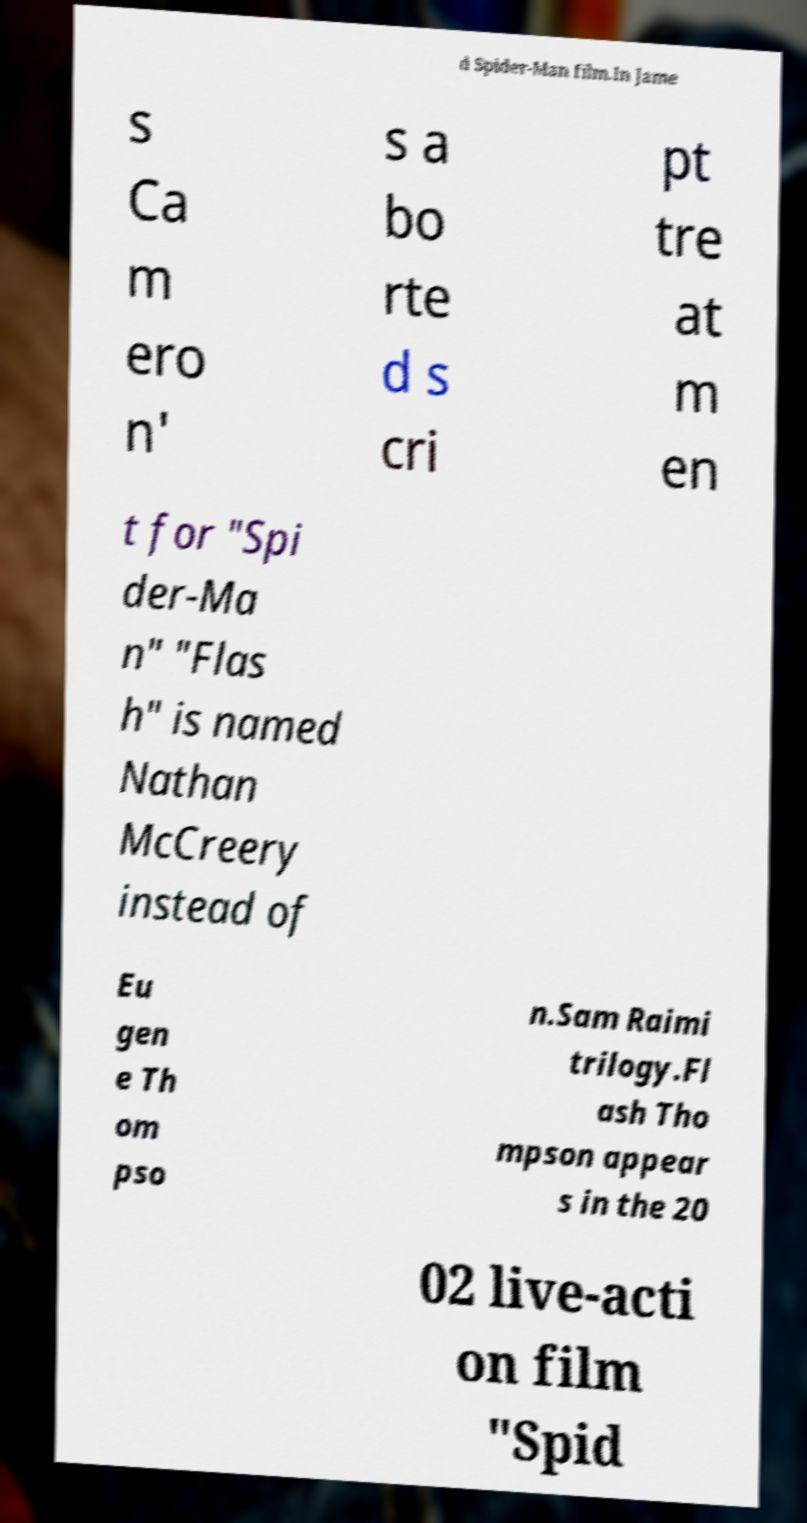For documentation purposes, I need the text within this image transcribed. Could you provide that? d Spider-Man film.In Jame s Ca m ero n' s a bo rte d s cri pt tre at m en t for "Spi der-Ma n" "Flas h" is named Nathan McCreery instead of Eu gen e Th om pso n.Sam Raimi trilogy.Fl ash Tho mpson appear s in the 20 02 live-acti on film "Spid 